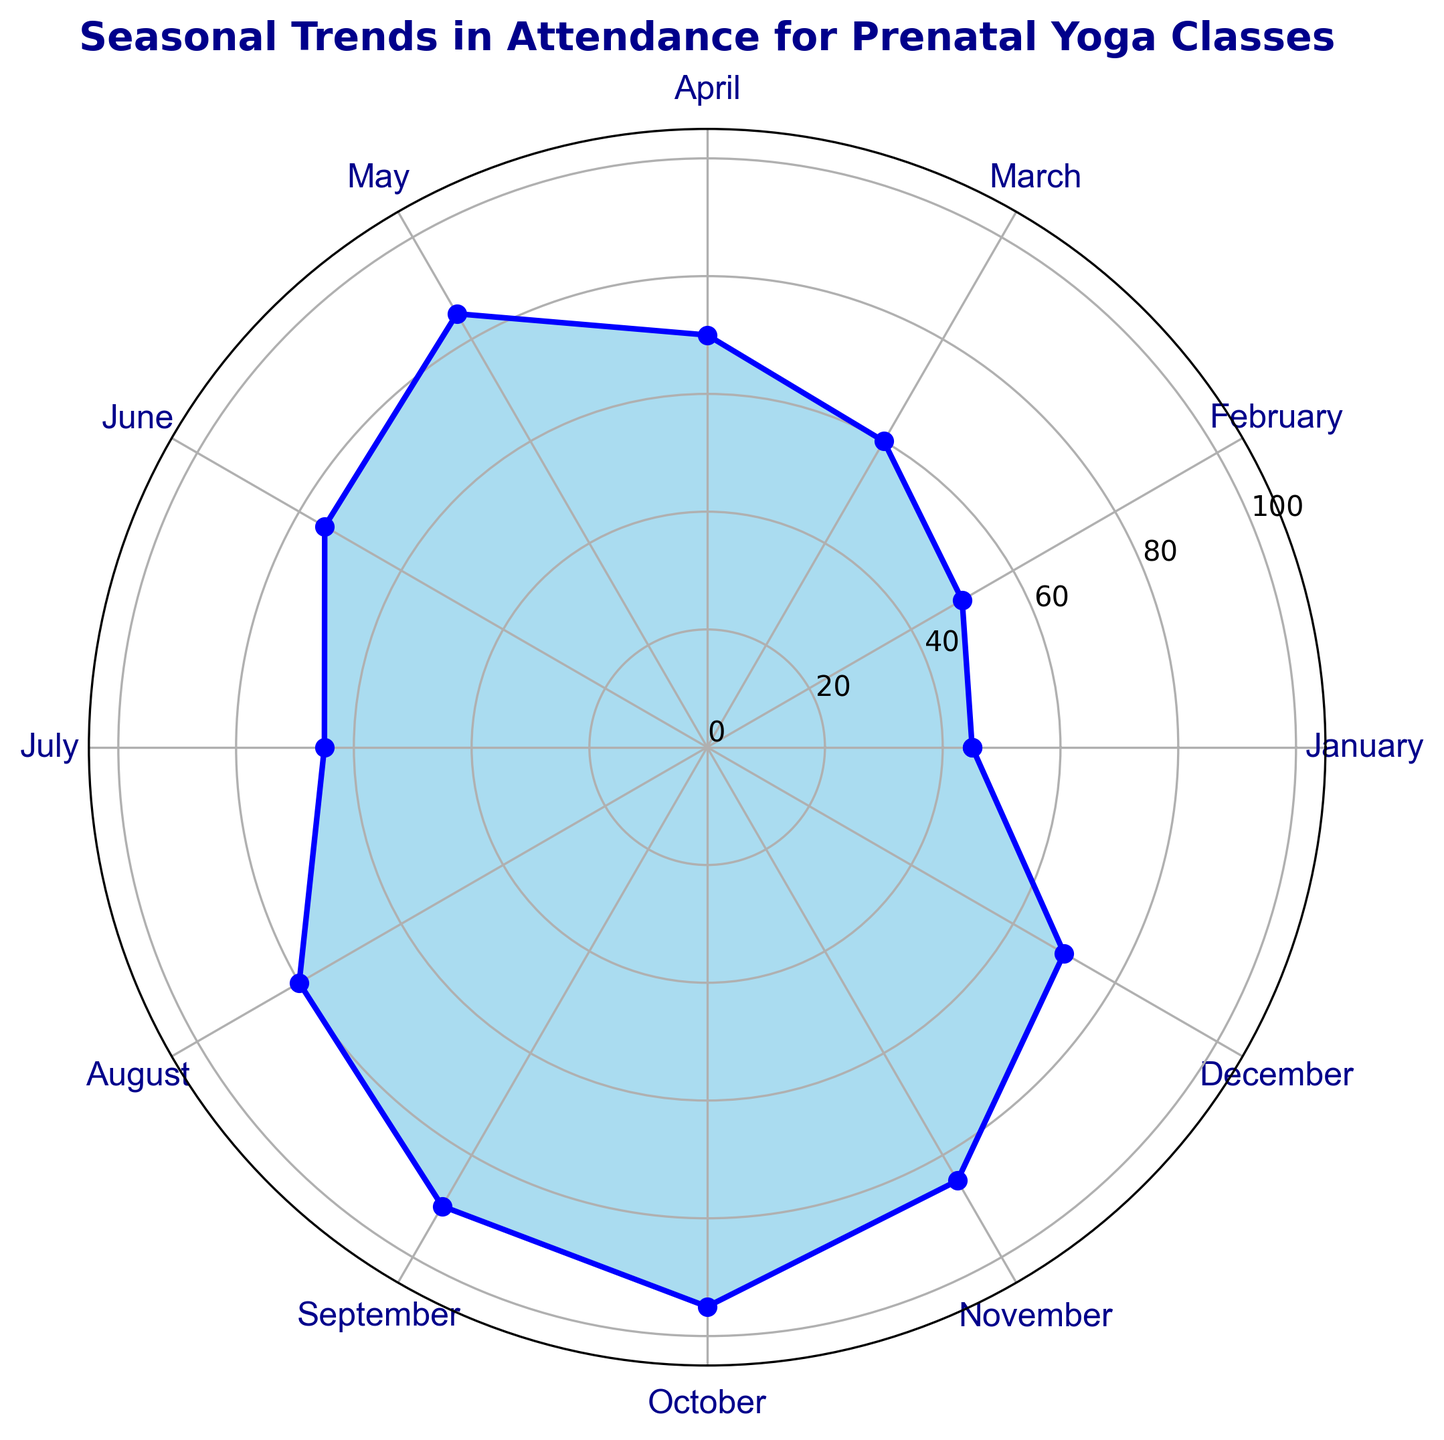What is the overall trend in attendance throughout the year? The rose chart shows a general increase in attendance from January to October, peaking in October, and then a slight decrease in November and December.
Answer: Increasing and then decreasing Which month has the highest attendance? The peak of the rose chart is highest in October, which indicates maximum attendance.
Answer: October How much higher is the attendance in May compared to January? The attendance in May is 85 and in January is 45, so the difference is 85 - 45.
Answer: 40 During which two consecutive months is the increase in attendance the greatest? From the rose chart, the largest consecutive increase appears between April (70) and May (85).
Answer: April to May What is the average attendance for the months of August, September, October, and November? The attendance for these months is 80, 90, 95, and 85 respectively. The average is (80 + 90 + 95 + 85) / 4.
Answer: 87.5 Is the attendance in December higher or lower than in June? The attendance in June is 75, and in December, it is 70, so December is lower.
Answer: Lower What visual indicator shows the months with the least attendance? The shorter radial lengths on the rose chart indicate months with the least attendance, which are January and February.
Answer: Shorter radial lengths Compare the July and November attendance. July has an attendance of 65, while November has 85. November is higher than July.
Answer: November How does the attendance in February compare to the attendance in August? February has an attendance of 50, while August has 80, so August is higher than February.
Answer: August What are the median attendance values in the first half and the second half of the year, from January to June and July to December? For January to June, the attendances are 45, 50, 60, 70, 85, 75. The median is the average of the third and fourth values: (60 + 70) / 2 = 65. For July to December, the attendances are 65, 80, 90, 95, 85, 70. The median is the average of the third and fourth values: (90 + 95) / 2 = 92.5.
Answer: 65 and 92.5 